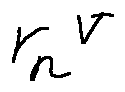<formula> <loc_0><loc_0><loc_500><loc_500>r _ { n } ^ { V }</formula> 